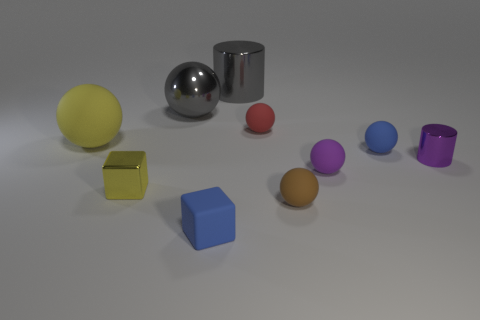Subtract all brown rubber spheres. How many spheres are left? 5 Subtract 2 spheres. How many spheres are left? 4 Subtract all gray spheres. How many spheres are left? 5 Subtract all brown balls. Subtract all green cylinders. How many balls are left? 5 Subtract all spheres. How many objects are left? 4 Subtract all gray balls. Subtract all yellow balls. How many objects are left? 8 Add 6 large gray things. How many large gray things are left? 8 Add 9 large brown shiny cylinders. How many large brown shiny cylinders exist? 9 Subtract 0 yellow cylinders. How many objects are left? 10 